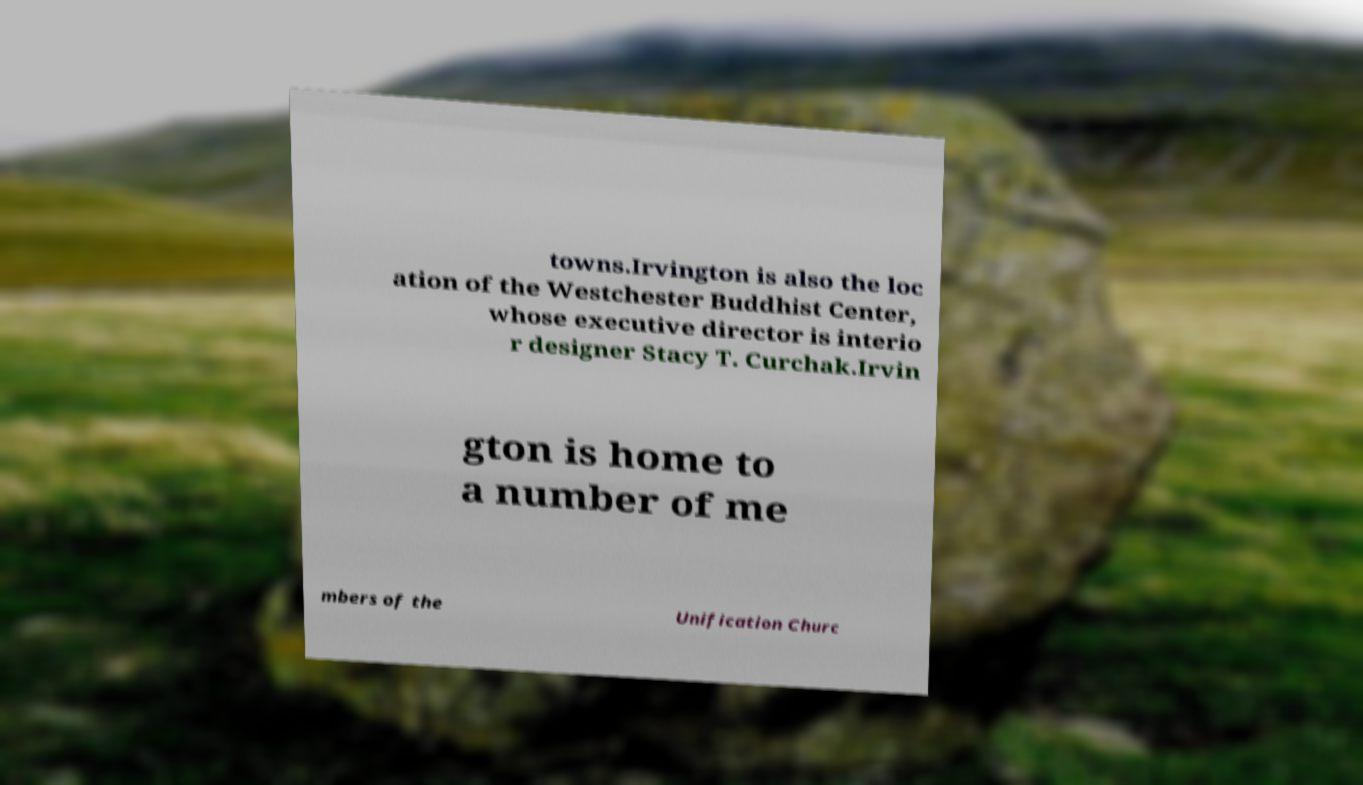Could you assist in decoding the text presented in this image and type it out clearly? towns.Irvington is also the loc ation of the Westchester Buddhist Center, whose executive director is interio r designer Stacy T. Curchak.Irvin gton is home to a number of me mbers of the Unification Churc 